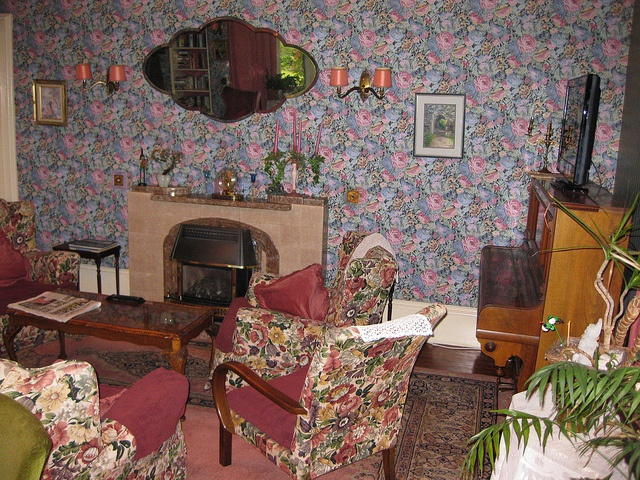Describe the objects in this image and their specific colors. I can see chair in black, brown, maroon, gray, and tan tones, couch in black, brown, and tan tones, potted plant in black, darkgreen, gray, and olive tones, chair in black, brown, gray, and tan tones, and potted plant in black, brown, and olive tones in this image. 